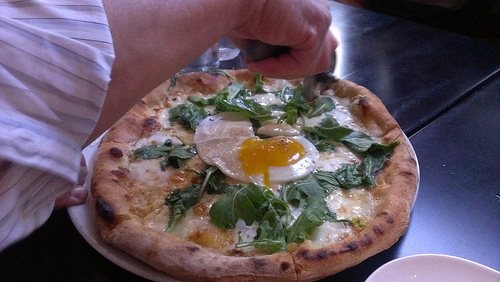What type of vegetable is to the right of the egg in the center of the image? The vegetable to the right of the egg in the center of the image is spinach. 